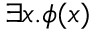Convert formula to latex. <formula><loc_0><loc_0><loc_500><loc_500>\exists x . \phi ( x )</formula> 